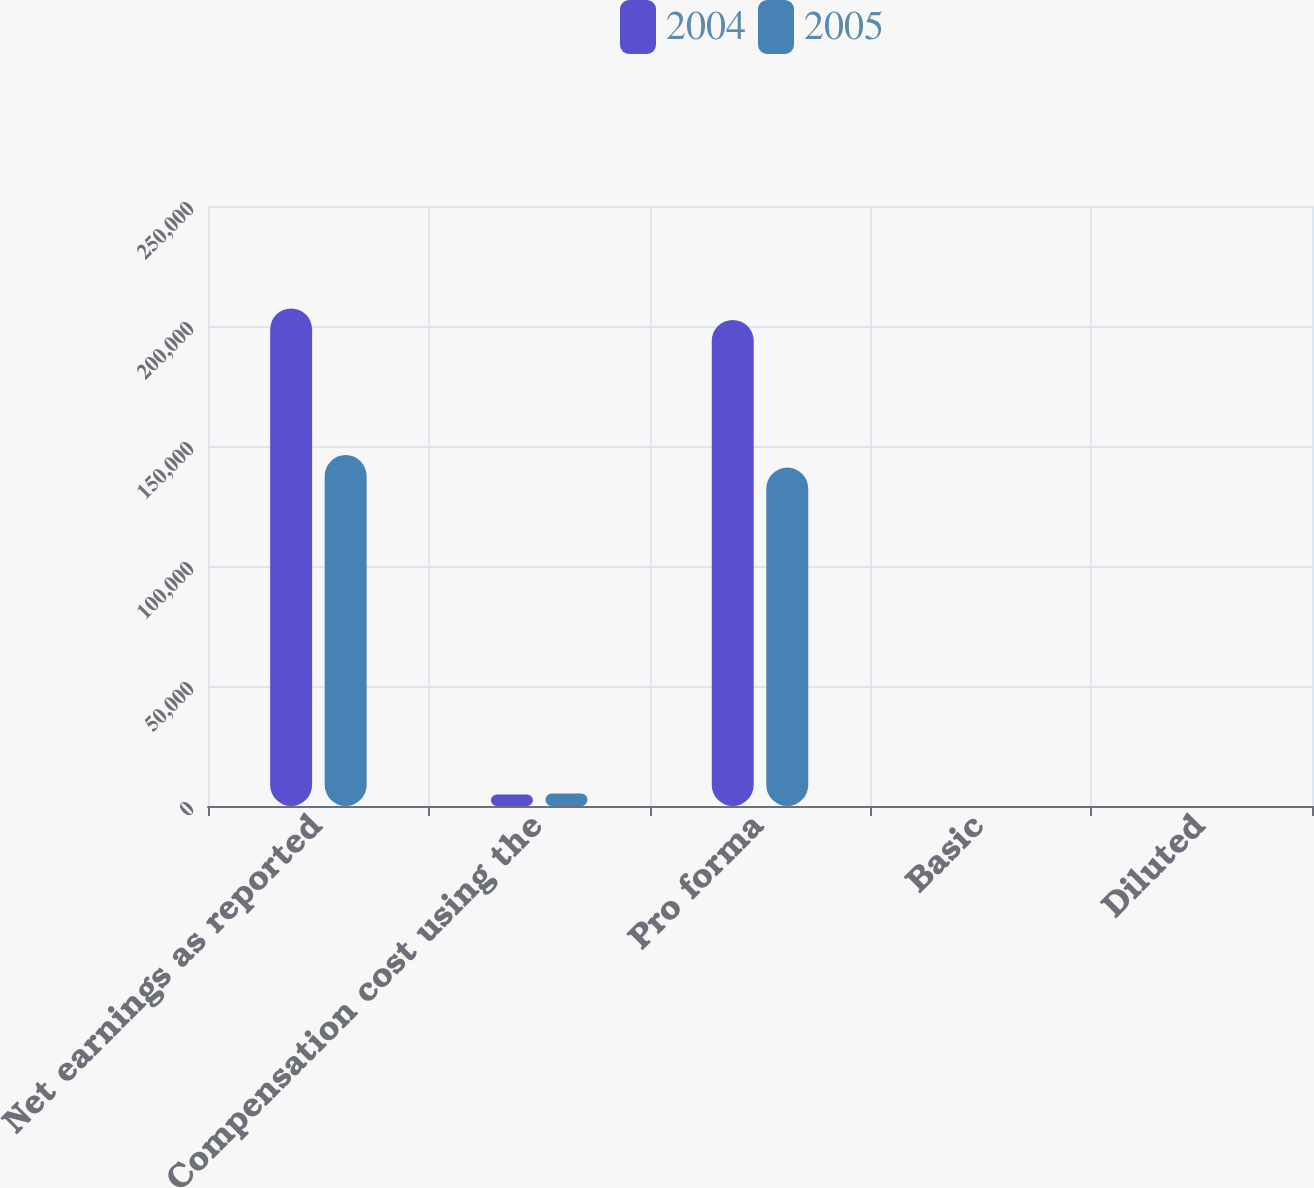Convert chart. <chart><loc_0><loc_0><loc_500><loc_500><stacked_bar_chart><ecel><fcel>Net earnings as reported<fcel>Compensation cost using the<fcel>Pro forma<fcel>Basic<fcel>Diluted<nl><fcel>2004<fcel>207311<fcel>4765<fcel>202546<fcel>1.32<fcel>1.28<nl><fcel>2005<fcel>146256<fcel>5246<fcel>141010<fcel>0.91<fcel>0.88<nl></chart> 